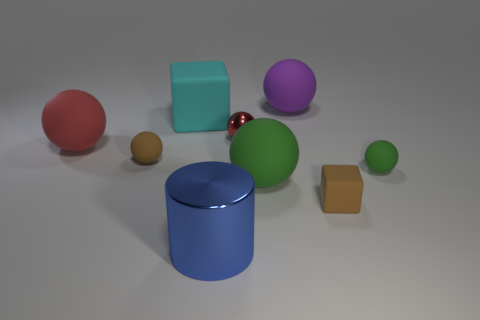What is the color of the large block that is made of the same material as the big purple thing?
Provide a short and direct response. Cyan. What color is the cube that is the same size as the blue metal object?
Provide a short and direct response. Cyan. Is there any other thing that is the same color as the tiny shiny object?
Ensure brevity in your answer.  Yes. What is the size of the red sphere to the left of the tiny matte thing to the left of the blue metal cylinder?
Offer a very short reply. Large. Is there anything else that is made of the same material as the cyan block?
Ensure brevity in your answer.  Yes. Are there more red shiny balls than big matte balls?
Offer a very short reply. No. Is the color of the sphere that is to the left of the tiny brown ball the same as the shiny cylinder left of the purple matte object?
Your answer should be very brief. No. There is a red object that is on the right side of the blue metal cylinder; are there any tiny matte things that are left of it?
Offer a very short reply. Yes. Is the number of brown rubber spheres that are to the left of the brown block less than the number of small brown matte spheres to the right of the big cylinder?
Provide a succinct answer. No. Is the small sphere that is behind the large red sphere made of the same material as the brown thing that is on the left side of the big green thing?
Your answer should be very brief. No. 